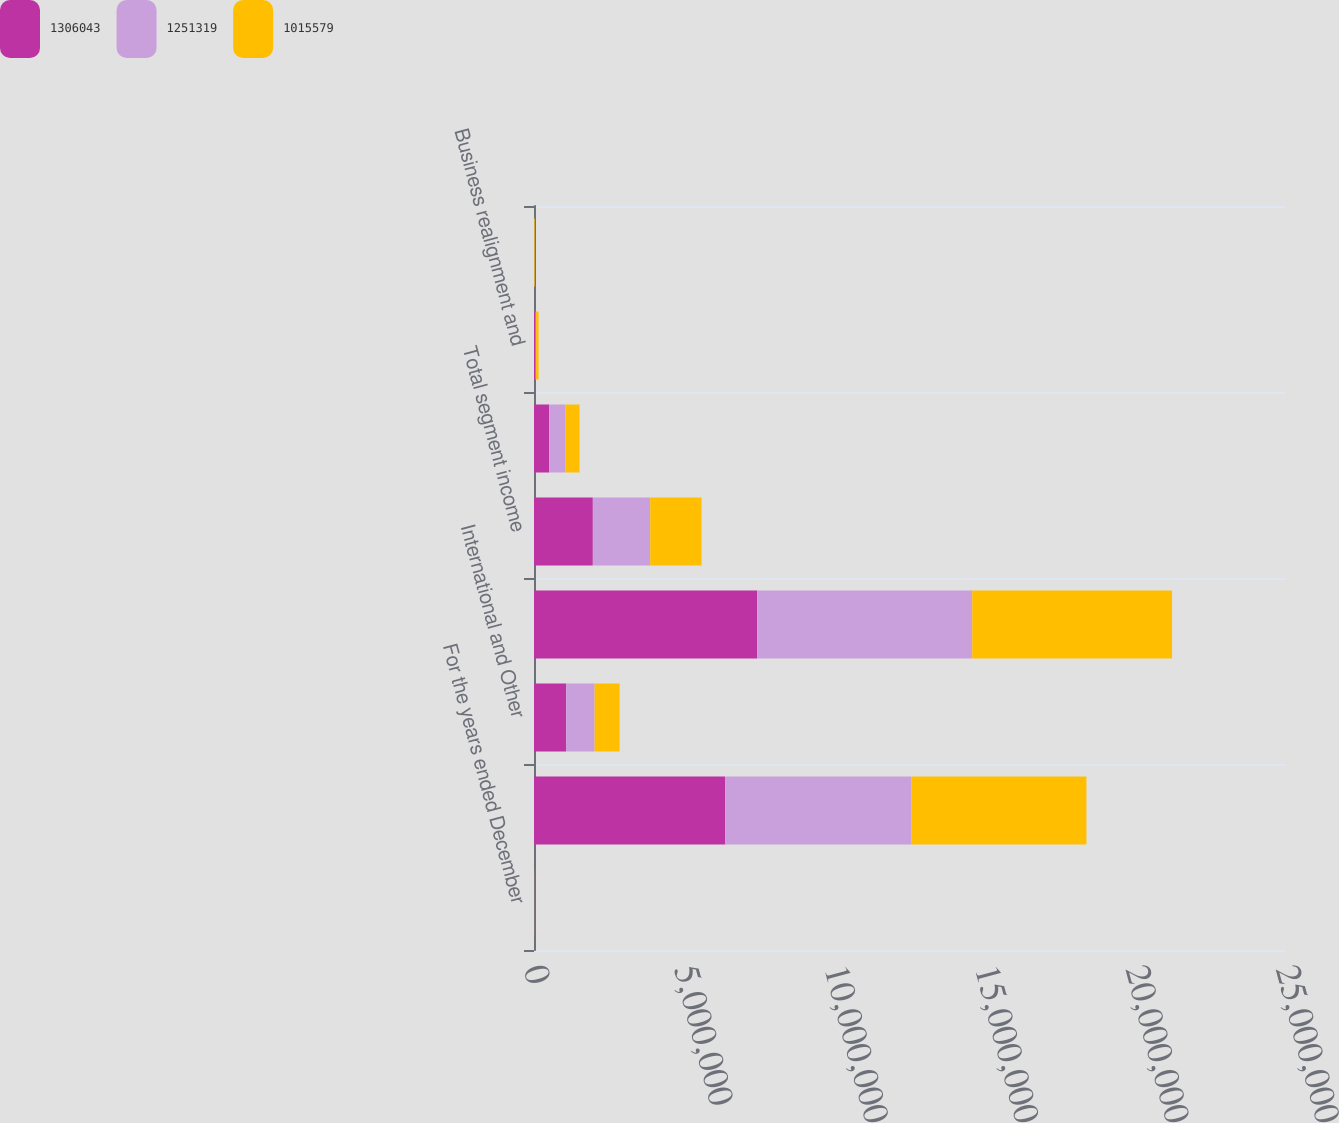Convert chart to OTSL. <chart><loc_0><loc_0><loc_500><loc_500><stacked_bar_chart><ecel><fcel>For the years ended December<fcel>North America<fcel>International and Other<fcel>Total<fcel>Total segment income<fcel>Unallocated corporate expense<fcel>Business realignment and<fcel>Non-service related pension<nl><fcel>1.30604e+06<fcel>2014<fcel>6.35273e+06<fcel>1.06904e+06<fcel>7.42177e+06<fcel>1.95621e+06<fcel>503407<fcel>50190<fcel>1834<nl><fcel>1.25132e+06<fcel>2013<fcel>6.20012e+06<fcel>945961<fcel>7.14608e+06<fcel>1.90722e+06<fcel>533506<fcel>19085<fcel>10885<nl><fcel>1.01558e+06<fcel>2012<fcel>5.81264e+06<fcel>831613<fcel>6.64425e+06<fcel>1.70751e+06<fcel>478645<fcel>83767<fcel>20572<nl></chart> 